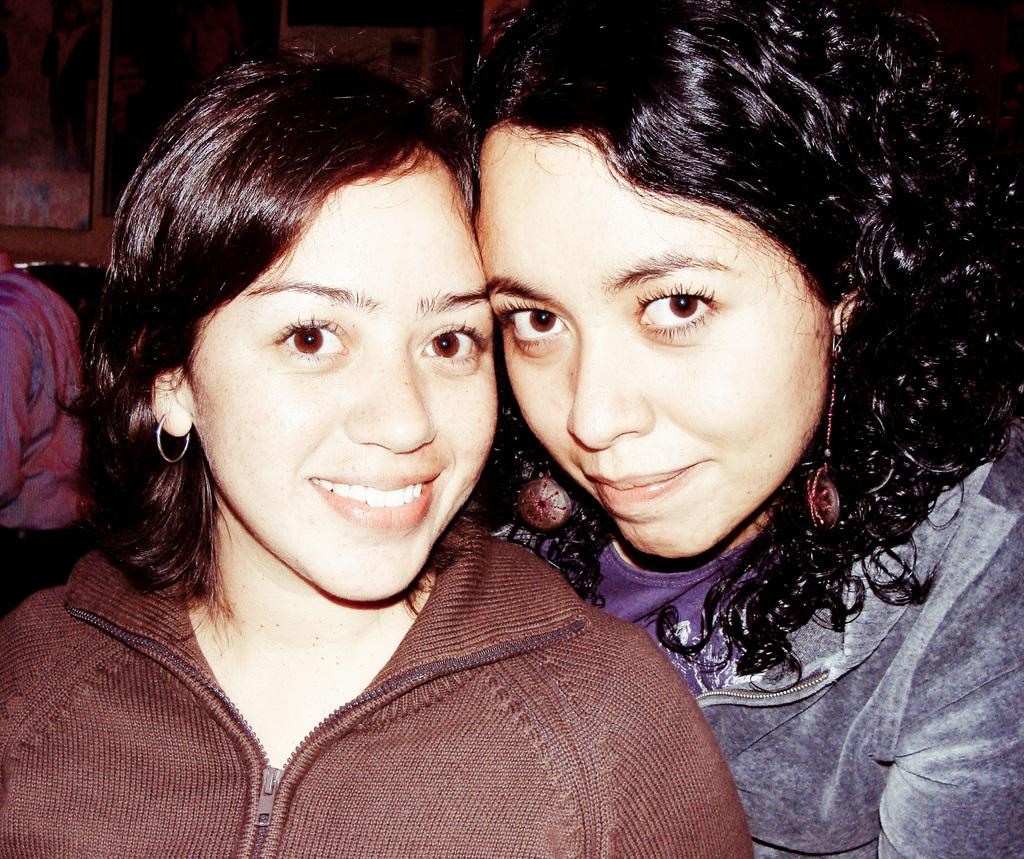How many women are in the image? There are two women in the image. Can you describe the position of one of the women? One of the women is on the right side. What is the woman on the right side wearing? The woman on the right side is wearing a blue jacket. What can be observed about the background of the image? The background of the image is dark. How many passengers are in the carriage in the image? There is no carriage present in the image. What type of crib is visible in the image? There is no crib present in the image. 